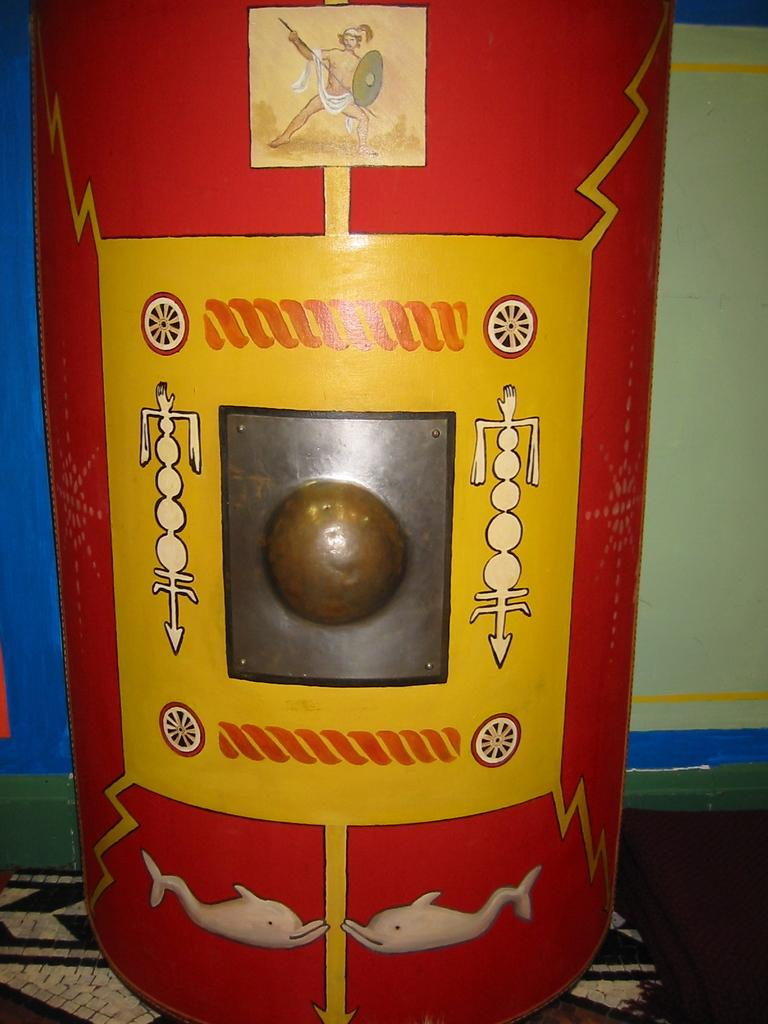What is the main subject of the image? There is an object in the image. Can you describe the appearance of the object? The object has various colors painted on it. How many mice are climbing up the rod in the image? There is no rod or mice present in the image. What type of education is being provided in the image? There is no indication of any educational activity or subject in the image. 